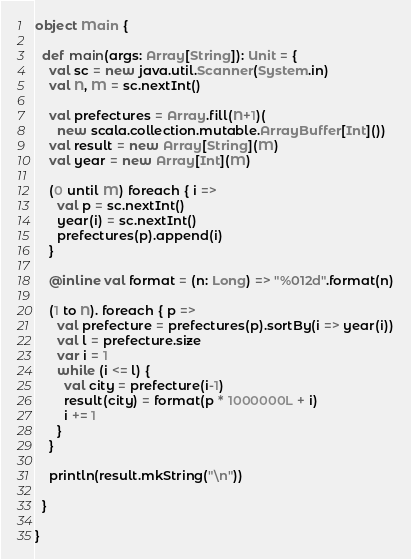Convert code to text. <code><loc_0><loc_0><loc_500><loc_500><_Scala_>object Main {

  def main(args: Array[String]): Unit = {
    val sc = new java.util.Scanner(System.in)
    val N, M = sc.nextInt()

    val prefectures = Array.fill(N+1)(
      new scala.collection.mutable.ArrayBuffer[Int]())
    val result = new Array[String](M)
    val year = new Array[Int](M)

    (0 until M) foreach { i =>
      val p = sc.nextInt()
      year(i) = sc.nextInt()
      prefectures(p).append(i)
    }

    @inline val format = (n: Long) => "%012d".format(n)

    (1 to N). foreach { p =>
      val prefecture = prefectures(p).sortBy(i => year(i))
      val l = prefecture.size
      var i = 1
      while (i <= l) {
        val city = prefecture(i-1)
        result(city) = format(p * 1000000L + i)
        i += 1
      }
    }

    println(result.mkString("\n"))

  }

}
</code> 